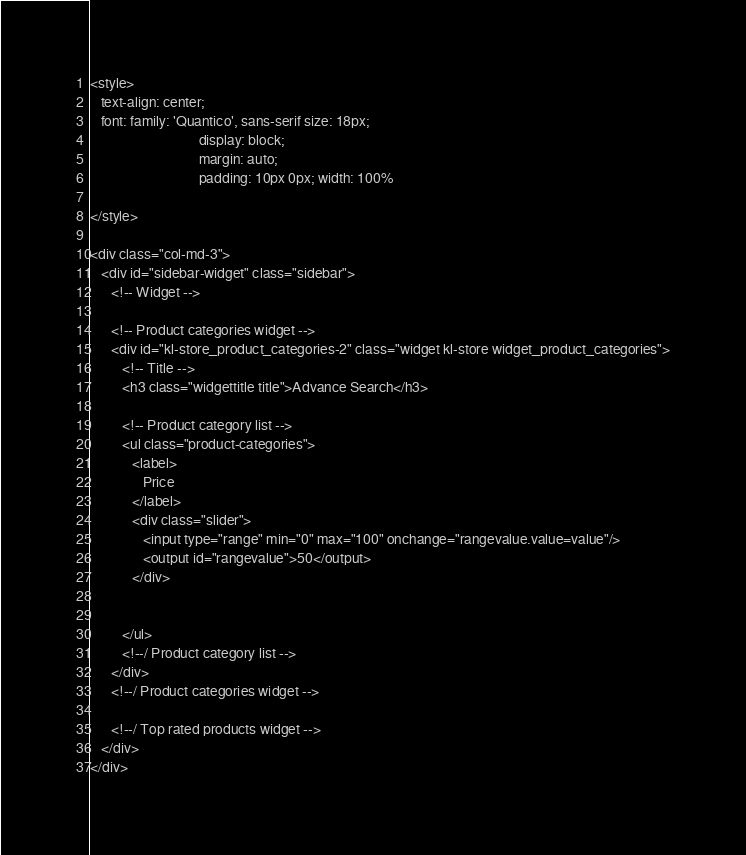<code> <loc_0><loc_0><loc_500><loc_500><_PHP_><style>
   text-align: center;
   font: family: 'Quantico', sans-serif size: 18px;
                               display: block;
                               margin: auto;
                               padding: 10px 0px; width: 100%

</style>

<div class="col-md-3">
   <div id="sidebar-widget" class="sidebar">
      <!-- Widget -->

      <!-- Product categories widget -->
      <div id="kl-store_product_categories-2" class="widget kl-store widget_product_categories">
         <!-- Title -->
         <h3 class="widgettitle title">Advance Search</h3>

         <!-- Product category list -->
         <ul class="product-categories">
            <label>
               Price
            </label>
            <div class="slider">
               <input type="range" min="0" max="100" onchange="rangevalue.value=value"/>
               <output id="rangevalue">50</output>
            </div>


         </ul>
         <!--/ Product category list -->
      </div>
      <!--/ Product categories widget -->

      <!--/ Top rated products widget -->
   </div>
</div></code> 